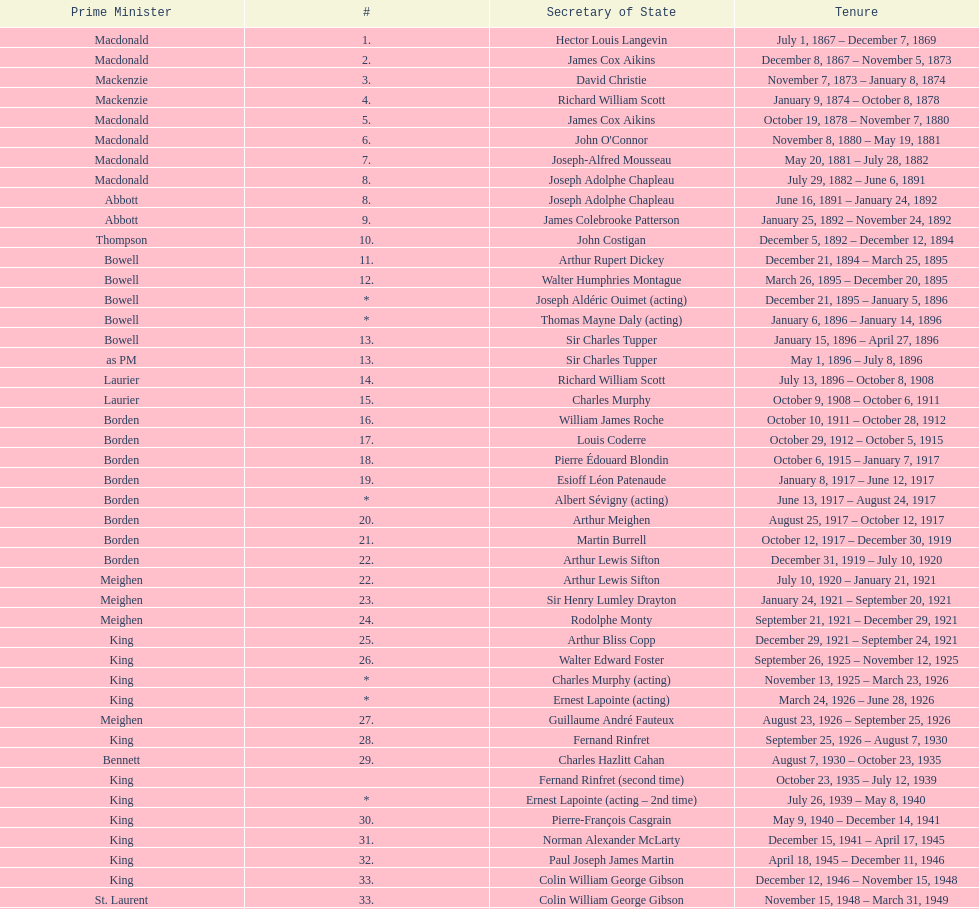Was macdonald prime minister before or after bowell? Before. Write the full table. {'header': ['Prime Minister', '#', 'Secretary of State', 'Tenure'], 'rows': [['Macdonald', '1.', 'Hector Louis Langevin', 'July 1, 1867 – December 7, 1869'], ['Macdonald', '2.', 'James Cox Aikins', 'December 8, 1867 – November 5, 1873'], ['Mackenzie', '3.', 'David Christie', 'November 7, 1873 – January 8, 1874'], ['Mackenzie', '4.', 'Richard William Scott', 'January 9, 1874 – October 8, 1878'], ['Macdonald', '5.', 'James Cox Aikins', 'October 19, 1878 – November 7, 1880'], ['Macdonald', '6.', "John O'Connor", 'November 8, 1880 – May 19, 1881'], ['Macdonald', '7.', 'Joseph-Alfred Mousseau', 'May 20, 1881 – July 28, 1882'], ['Macdonald', '8.', 'Joseph Adolphe Chapleau', 'July 29, 1882 – June 6, 1891'], ['Abbott', '8.', 'Joseph Adolphe Chapleau', 'June 16, 1891 – January 24, 1892'], ['Abbott', '9.', 'James Colebrooke Patterson', 'January 25, 1892 – November 24, 1892'], ['Thompson', '10.', 'John Costigan', 'December 5, 1892 – December 12, 1894'], ['Bowell', '11.', 'Arthur Rupert Dickey', 'December 21, 1894 – March 25, 1895'], ['Bowell', '12.', 'Walter Humphries Montague', 'March 26, 1895 – December 20, 1895'], ['Bowell', '*', 'Joseph Aldéric Ouimet (acting)', 'December 21, 1895 – January 5, 1896'], ['Bowell', '*', 'Thomas Mayne Daly (acting)', 'January 6, 1896 – January 14, 1896'], ['Bowell', '13.', 'Sir Charles Tupper', 'January 15, 1896 – April 27, 1896'], ['as PM', '13.', 'Sir Charles Tupper', 'May 1, 1896 – July 8, 1896'], ['Laurier', '14.', 'Richard William Scott', 'July 13, 1896 – October 8, 1908'], ['Laurier', '15.', 'Charles Murphy', 'October 9, 1908 – October 6, 1911'], ['Borden', '16.', 'William James Roche', 'October 10, 1911 – October 28, 1912'], ['Borden', '17.', 'Louis Coderre', 'October 29, 1912 – October 5, 1915'], ['Borden', '18.', 'Pierre Édouard Blondin', 'October 6, 1915 – January 7, 1917'], ['Borden', '19.', 'Esioff Léon Patenaude', 'January 8, 1917 – June 12, 1917'], ['Borden', '*', 'Albert Sévigny (acting)', 'June 13, 1917 – August 24, 1917'], ['Borden', '20.', 'Arthur Meighen', 'August 25, 1917 – October 12, 1917'], ['Borden', '21.', 'Martin Burrell', 'October 12, 1917 – December 30, 1919'], ['Borden', '22.', 'Arthur Lewis Sifton', 'December 31, 1919 – July 10, 1920'], ['Meighen', '22.', 'Arthur Lewis Sifton', 'July 10, 1920 – January 21, 1921'], ['Meighen', '23.', 'Sir Henry Lumley Drayton', 'January 24, 1921 – September 20, 1921'], ['Meighen', '24.', 'Rodolphe Monty', 'September 21, 1921 – December 29, 1921'], ['King', '25.', 'Arthur Bliss Copp', 'December 29, 1921 – September 24, 1921'], ['King', '26.', 'Walter Edward Foster', 'September 26, 1925 – November 12, 1925'], ['King', '*', 'Charles Murphy (acting)', 'November 13, 1925 – March 23, 1926'], ['King', '*', 'Ernest Lapointe (acting)', 'March 24, 1926 – June 28, 1926'], ['Meighen', '27.', 'Guillaume André Fauteux', 'August 23, 1926 – September 25, 1926'], ['King', '28.', 'Fernand Rinfret', 'September 25, 1926 – August 7, 1930'], ['Bennett', '29.', 'Charles Hazlitt Cahan', 'August 7, 1930 – October 23, 1935'], ['King', '', 'Fernand Rinfret (second time)', 'October 23, 1935 – July 12, 1939'], ['King', '*', 'Ernest Lapointe (acting – 2nd time)', 'July 26, 1939 – May 8, 1940'], ['King', '30.', 'Pierre-François Casgrain', 'May 9, 1940 – December 14, 1941'], ['King', '31.', 'Norman Alexander McLarty', 'December 15, 1941 – April 17, 1945'], ['King', '32.', 'Paul Joseph James Martin', 'April 18, 1945 – December 11, 1946'], ['King', '33.', 'Colin William George Gibson', 'December 12, 1946 – November 15, 1948'], ['St. Laurent', '33.', 'Colin William George Gibson', 'November 15, 1948 – March 31, 1949'], ['St. Laurent', '34.', 'Frederick Gordon Bradley', 'March 31, 1949 – June 11, 1953'], ['St. Laurent', '35.', 'Jack Pickersgill', 'June 11, 1953 – June 30, 1954'], ['St. Laurent', '36.', 'Roch Pinard', 'July 1, 1954 – June 21, 1957'], ['Diefenbaker', '37.', 'Ellen Louks Fairclough', 'June 21, 1957 – May 11, 1958'], ['Diefenbaker', '38.', 'Henri Courtemanche', 'May 12, 1958 – June 19, 1960'], ['Diefenbaker', '*', 'Léon Balcer (acting minister)', 'June 21, 1960 – October 10, 1960'], ['Diefenbaker', '39.', 'Noël Dorion', 'October 11, 1960 – July 5, 1962'], ['Diefenbaker', '*', 'Léon Balcer (acting minister – 2nd time)', 'July 11, 1962 – August 8, 1962'], ['Diefenbaker', '40.', 'George Ernest Halpenny', 'August 9, 1962 – April 22, 1963'], ['Pearson', '', 'Jack Pickersgill (second time)', 'April 22, 1963 – February 2, 1964'], ['Pearson', '41.', 'Maurice Lamontagne', 'February 2, 1964 – December 17, 1965'], ['Pearson', '42.', 'Judy LaMarsh', 'December 17, 1965 – April 9, 1968'], ['Pearson', '*', 'John Joseph Connolly (acting minister)', 'April 10, 1968 – April 20, 1968'], ['Trudeau', '43.', 'Jean Marchand', 'April 20, 1968 – July 5, 1968'], ['Trudeau', '44.', 'Gérard Pelletier', 'July 5, 1968 – November 26, 1972'], ['Trudeau', '45.', 'James Hugh Faulkner', 'November 27, 1972 – September 13, 1976'], ['Trudeau', '46.', 'John Roberts', 'September 14, 1976 – June 3, 1979'], ['Clark', '47.', 'David MacDonald', 'June 4, 1979 – March 2, 1980'], ['Trudeau', '48.', 'Francis Fox', 'March 3, 1980 – September 21, 1981'], ['Trudeau', '49.', 'Gerald Regan', 'September 22, 1981 – October 5, 1982'], ['Trudeau', '50.', 'Serge Joyal', 'October 6, 1982 – June 29, 1984'], ['Turner', '50.', 'Serge Joyal', 'June 30, 1984 – September 16, 1984'], ['Mulroney', '51.', 'Walter McLean', 'September 17, 1984 – April 19, 1985'], ['Mulroney', '52.', 'Benoit Bouchard', 'April 20, 1985 – June 29, 1986'], ['Mulroney', '53.', 'David Crombie', 'June 30, 1986 – March 30, 1988'], ['Mulroney', '54.', 'Lucien Bouchard', 'March 31, 1988 – January 29, 1989'], ['Mulroney', '55.', 'Gerry Weiner', 'January 30, 1989 – April 20, 1991'], ['Mulroney', '56.', 'Robert de Cotret', 'April 21, 1991 – January 3, 1993'], ['Mulroney', '57.', 'Monique Landry', 'January 4, 1993 – June 24, 1993'], ['Campbell', '57.', 'Monique Landry', 'June 24, 1993 – November 3, 1993'], ['Chrétien', '58.', 'Sergio Marchi', 'November 4, 1993 – January 24, 1996'], ['Chrétien', '59.', 'Lucienne Robillard', 'January 25, 1996 – July 12, 1996']]} 